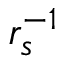Convert formula to latex. <formula><loc_0><loc_0><loc_500><loc_500>r _ { s } ^ { - 1 }</formula> 